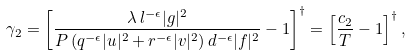<formula> <loc_0><loc_0><loc_500><loc_500>\gamma _ { 2 } = \left [ \frac { \lambda \, l ^ { - \epsilon } | g | ^ { 2 } } { P \left ( q ^ { - \epsilon } | u | ^ { 2 } + r ^ { - \epsilon } | v | ^ { 2 } \right ) d ^ { - \epsilon } | f | ^ { 2 } } - 1 \right ] ^ { \dag } = \left [ \frac { c _ { 2 } } { T } - 1 \right ] ^ { \dag } ,</formula> 